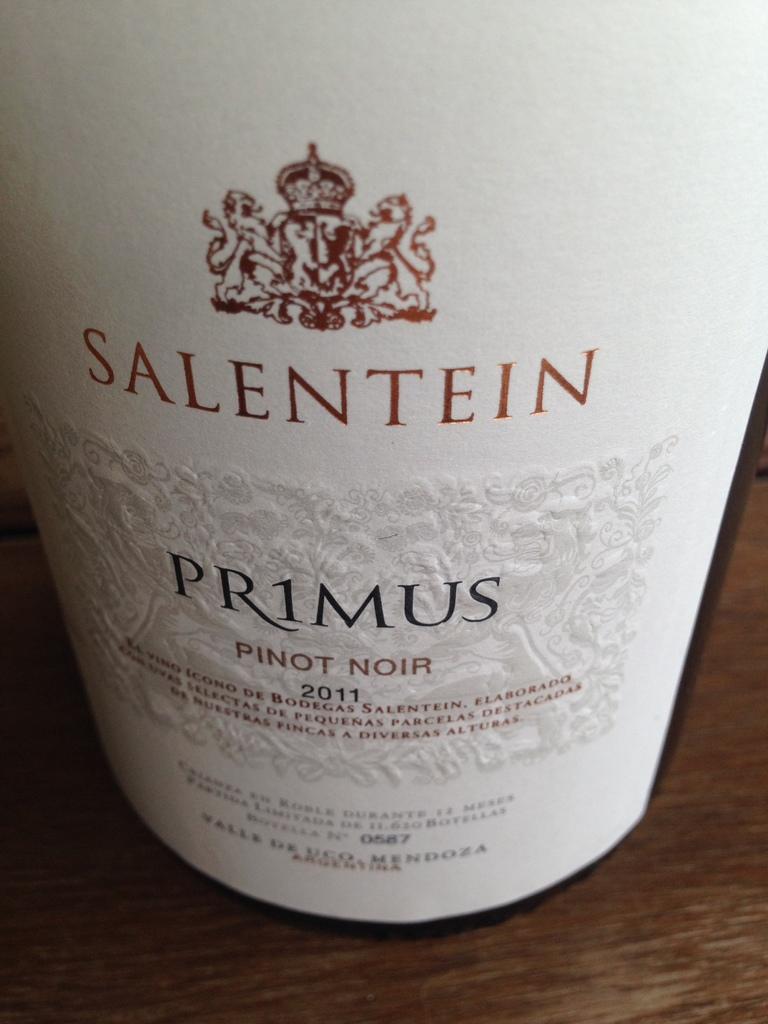What year was this made?
Offer a terse response. 2011. What is the brand?
Make the answer very short. Salentein. 